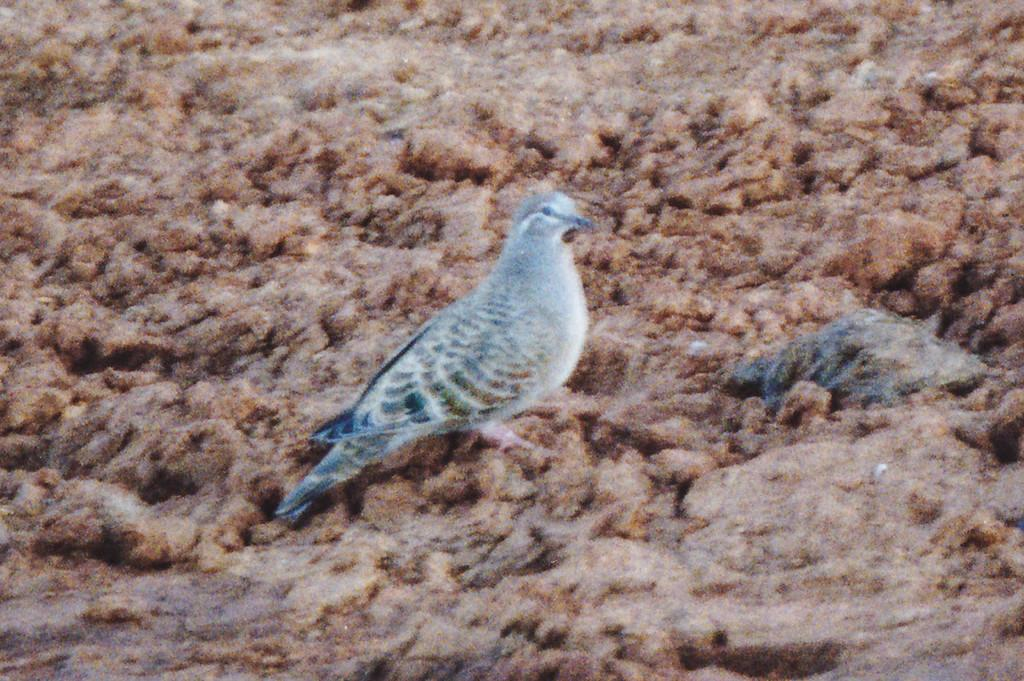What type of animal can be seen on the ground in the image? There is a bird on the ground in the image. What else is present on the ground in the image? There are objects on the ground in the image. What type of shop can be seen in the background of the image? There is no shop visible in the image; it only features a bird and objects on the ground. Is there any snow or coat present in the image? No, there is no snow or coat present in the image. 